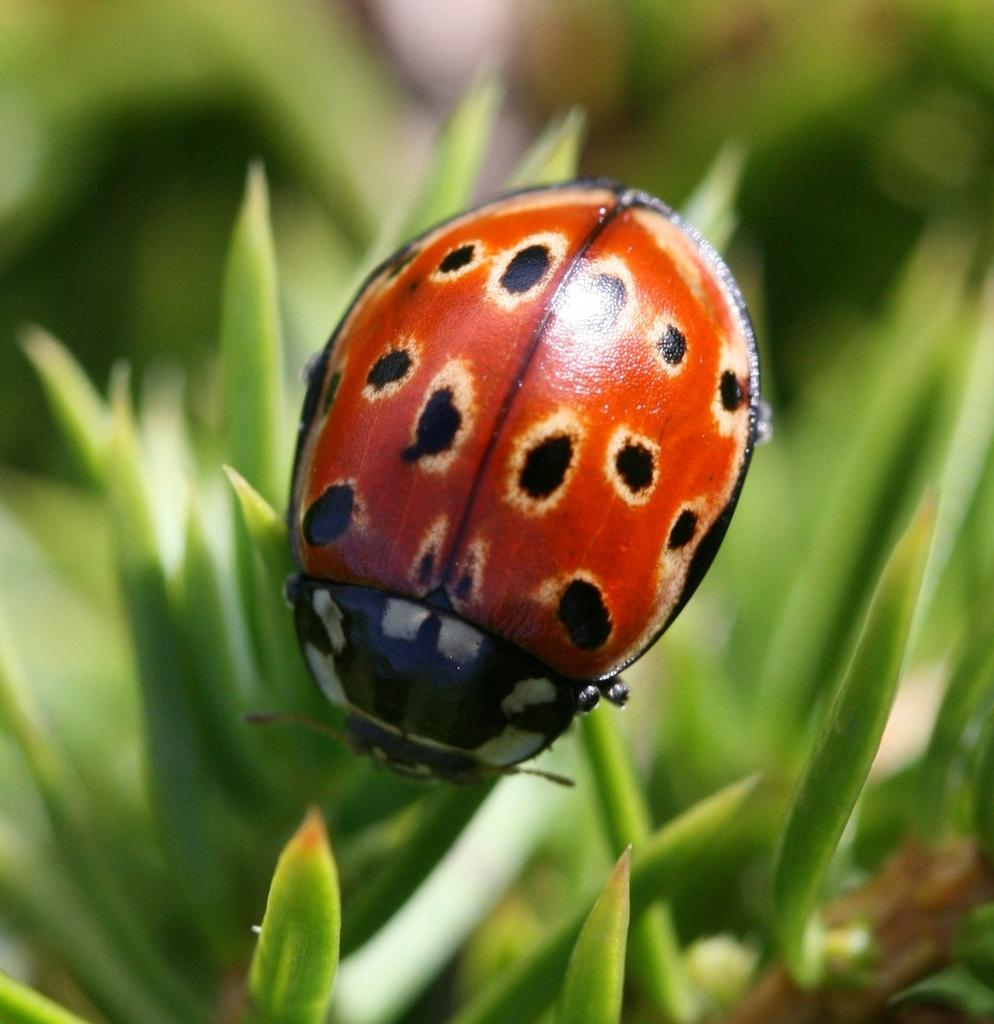What type of living organism can be seen in the image? There is an insect in the image. What else is present in the image besides the insect? There are plants in the image. Can you describe the background of the image? The background of the image is blurred. What finger is the insect using to solve the riddle in the image? There is no finger or riddle present in the image; it features an insect and plants with a blurred background. 